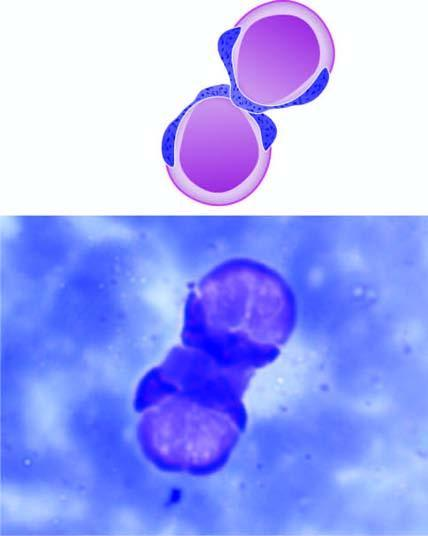re there two le cells having rounded masses of amorphous nuclear material which has displaced the lobes of neutrophil to the rim of the cell?
Answer the question using a single word or phrase. Yes 